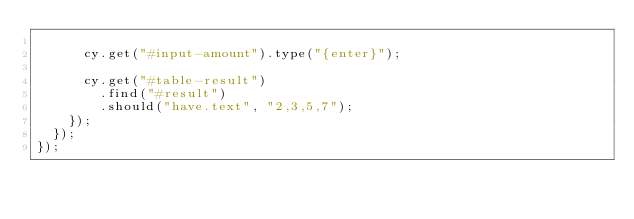<code> <loc_0><loc_0><loc_500><loc_500><_JavaScript_>
      cy.get("#input-amount").type("{enter}");

      cy.get("#table-result")
        .find("#result")
        .should("have.text", "2,3,5,7");
    });
  });
});
</code> 